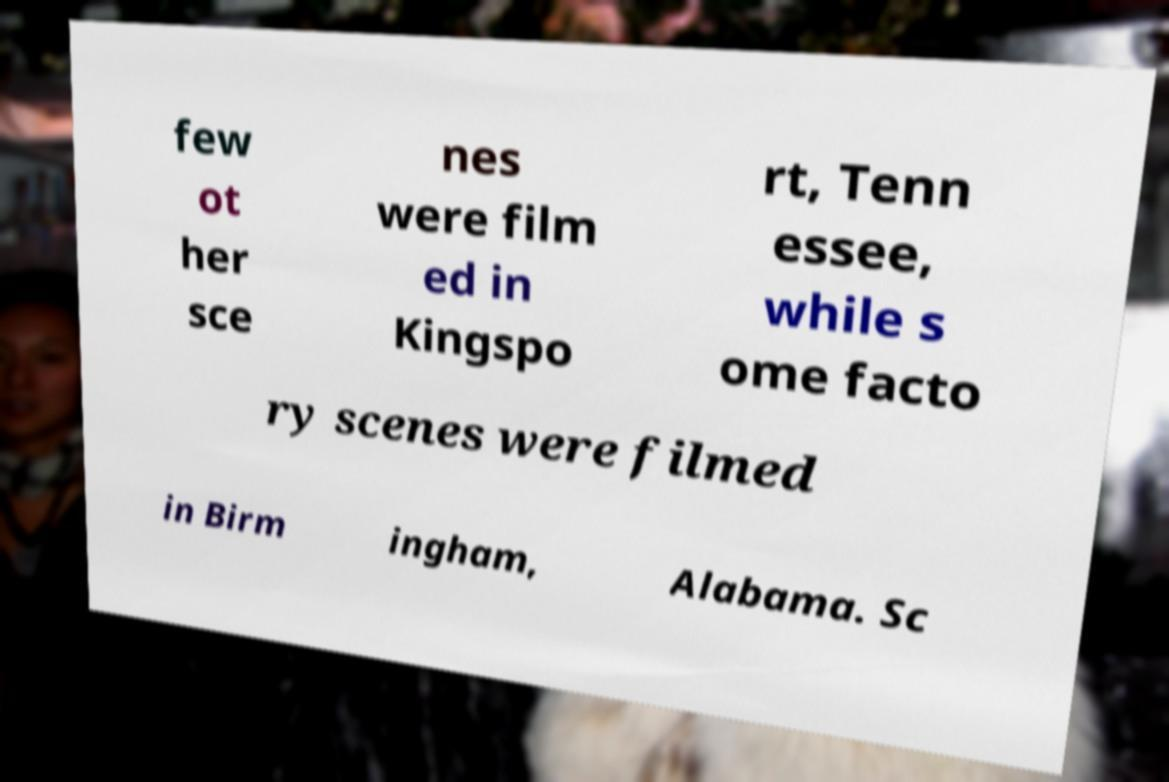What messages or text are displayed in this image? I need them in a readable, typed format. few ot her sce nes were film ed in Kingspo rt, Tenn essee, while s ome facto ry scenes were filmed in Birm ingham, Alabama. Sc 